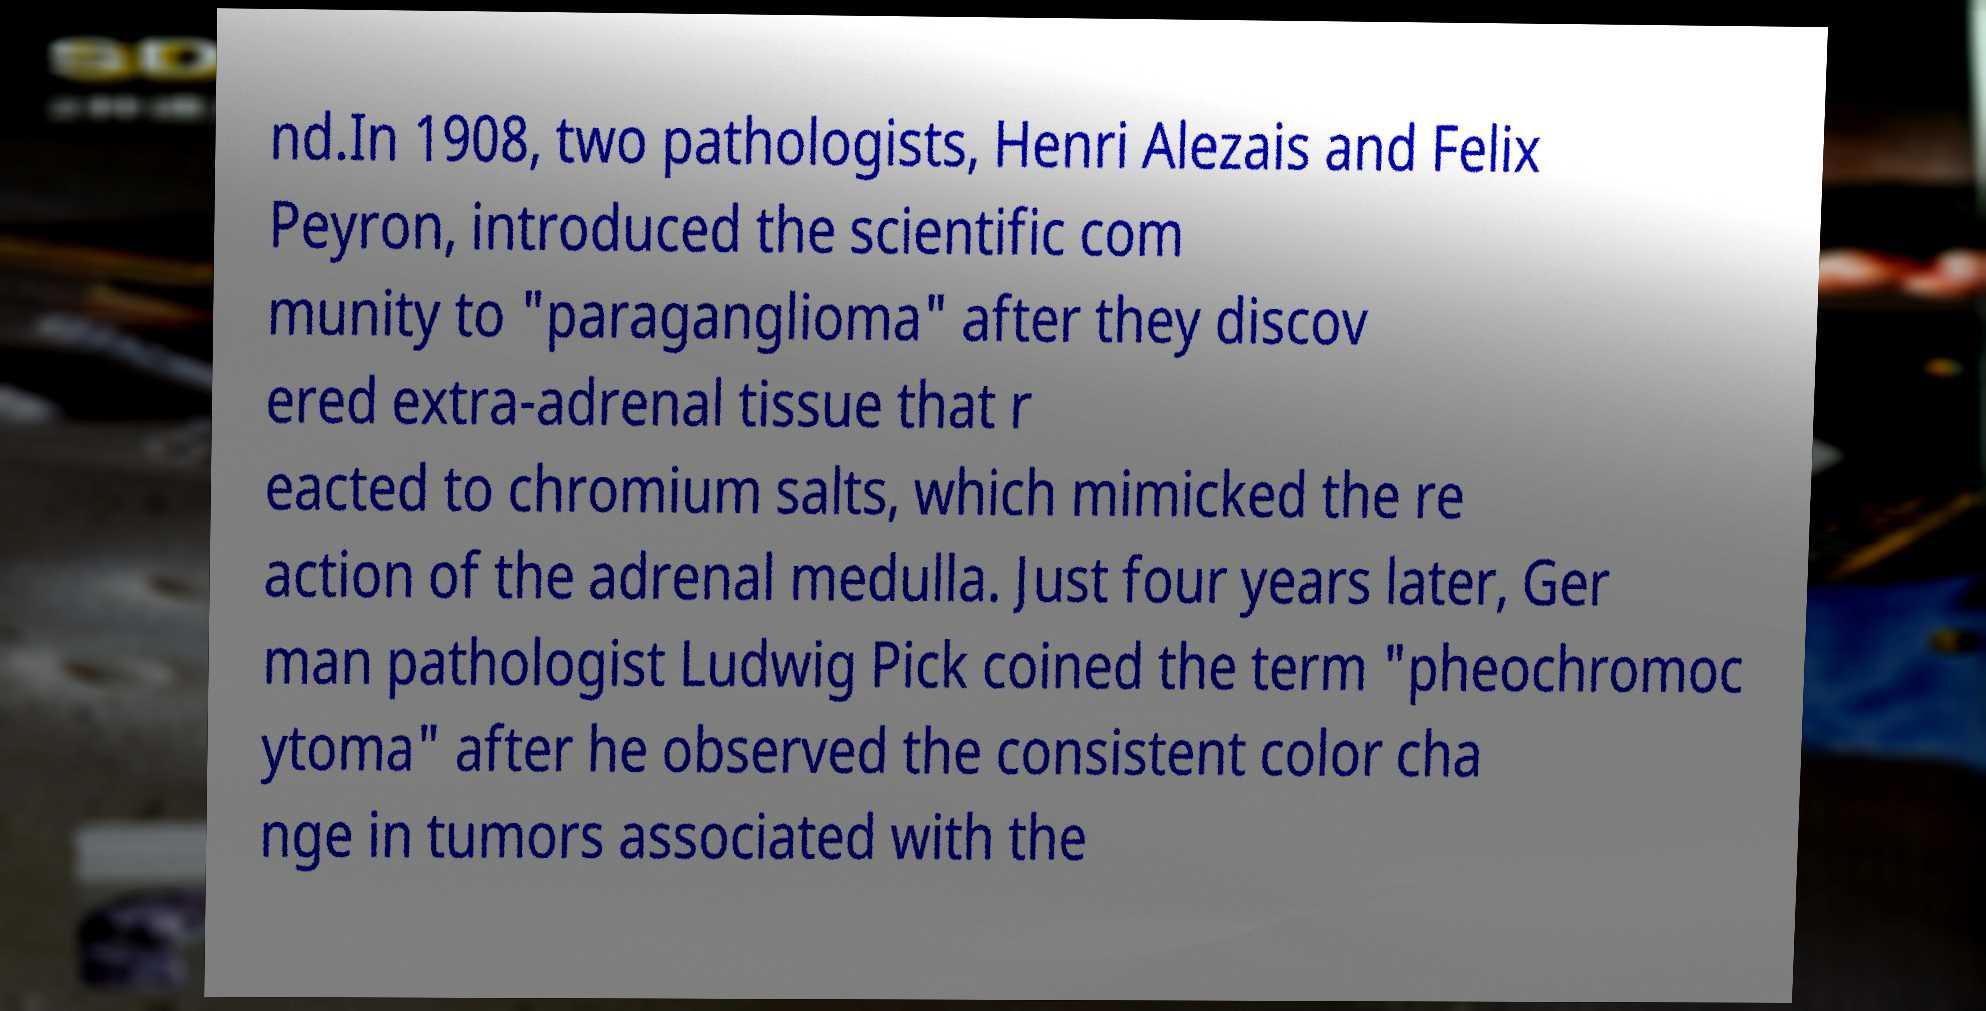Can you read and provide the text displayed in the image?This photo seems to have some interesting text. Can you extract and type it out for me? nd.In 1908, two pathologists, Henri Alezais and Felix Peyron, introduced the scientific com munity to "paraganglioma" after they discov ered extra-adrenal tissue that r eacted to chromium salts, which mimicked the re action of the adrenal medulla. Just four years later, Ger man pathologist Ludwig Pick coined the term "pheochromoc ytoma" after he observed the consistent color cha nge in tumors associated with the 